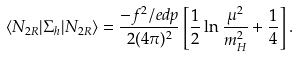Convert formula to latex. <formula><loc_0><loc_0><loc_500><loc_500>\langle N _ { 2 R } | \Sigma _ { h } | N _ { 2 R } \rangle = \frac { - f ^ { 2 } \slash e d { p } } { 2 ( 4 \pi ) ^ { 2 } } \left [ \frac { 1 } { 2 } \ln \frac { \mu ^ { 2 } } { m _ { H } ^ { 2 } } + \frac { 1 } { 4 } \right ] .</formula> 